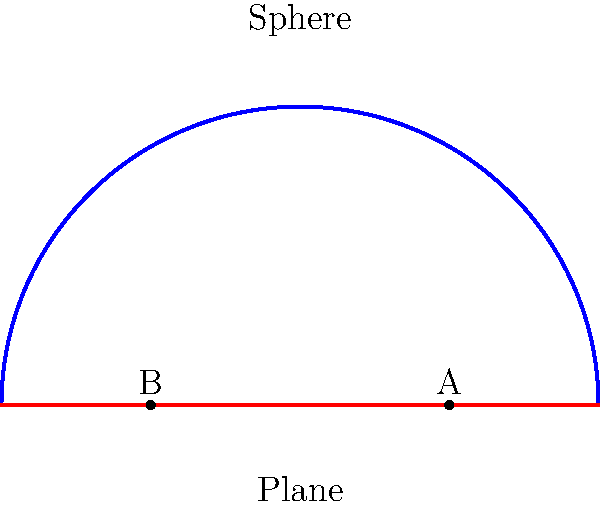As a PR manager for a popular science fiction TV show that explores concepts of curved space-time, you want to explain the difference between Euclidean and non-Euclidean geometry to a vlogger. Using the diagram, which shows two points A and B on both a sphere and a plane, explain why the shortest distance between these points differs in each geometry. How might this concept be relevant to a sci-fi plot involving space travel? 1. Euclidean Geometry (Plane):
   - On the plane (red line), the shortest distance between A and B is a straight line.
   - This is represented by the green solid line connecting A and B.
   - Distance formula: $d = \sqrt{(x_2-x_1)^2 + (y_2-y_1)^2}$

2. Non-Euclidean Geometry (Sphere):
   - On the sphere (blue curve), the shortest distance between A and B is along the surface.
   - This is represented by the green dashed curve (great circle arc).
   - Distance formula (spherical): $d = R \cdot \arccos(\sin\phi_1\sin\phi_2 + \cos\phi_1\cos\phi_2\cos(\lambda_2-\lambda_1))$
     Where R is the radius, $\phi$ is latitude, and $\lambda$ is longitude.

3. Key Differences:
   - Euclidean: Straight line, constant curvature of 0
   - Non-Euclidean: Curved line, positive curvature for sphere

4. Relevance to Sci-Fi Plot:
   - In curved space-time, the shortest path between two points might not be a straight line.
   - This could lead to plot elements such as:
     a) Wormholes as shortcuts through space
     b) Gravitational lensing affecting space travel routes
     c) Time dilation effects due to curved space-time

5. TV Show Application:
   - Visualize space as a curved surface rather than a flat plane
   - Demonstrate how spacecraft might navigate using non-Euclidean principles
   - Explore paradoxes or unexpected consequences of traveling through curved space-time
Answer: Non-Euclidean geometry on curved surfaces (like a sphere) results in shorter distances along surface curves rather than straight lines, applicable to sci-fi concepts like wormholes and space-time distortions in interstellar travel. 